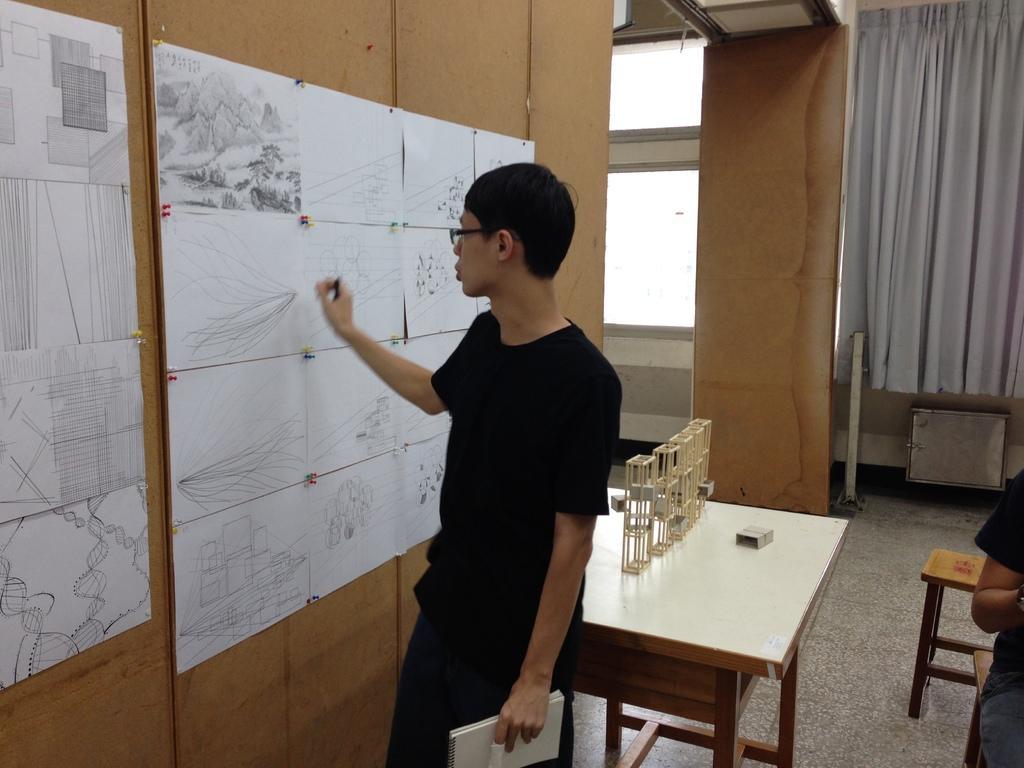Can you describe this image briefly? In this image there is a person wearing black color T-shirt holding book on his left hand and pen in his right hand and at the left side of the image there are paintings attached to the wooden sheet and at the middle of the image there are wooden blocks which are on the table and at the background of the image there is a white color curtain. 